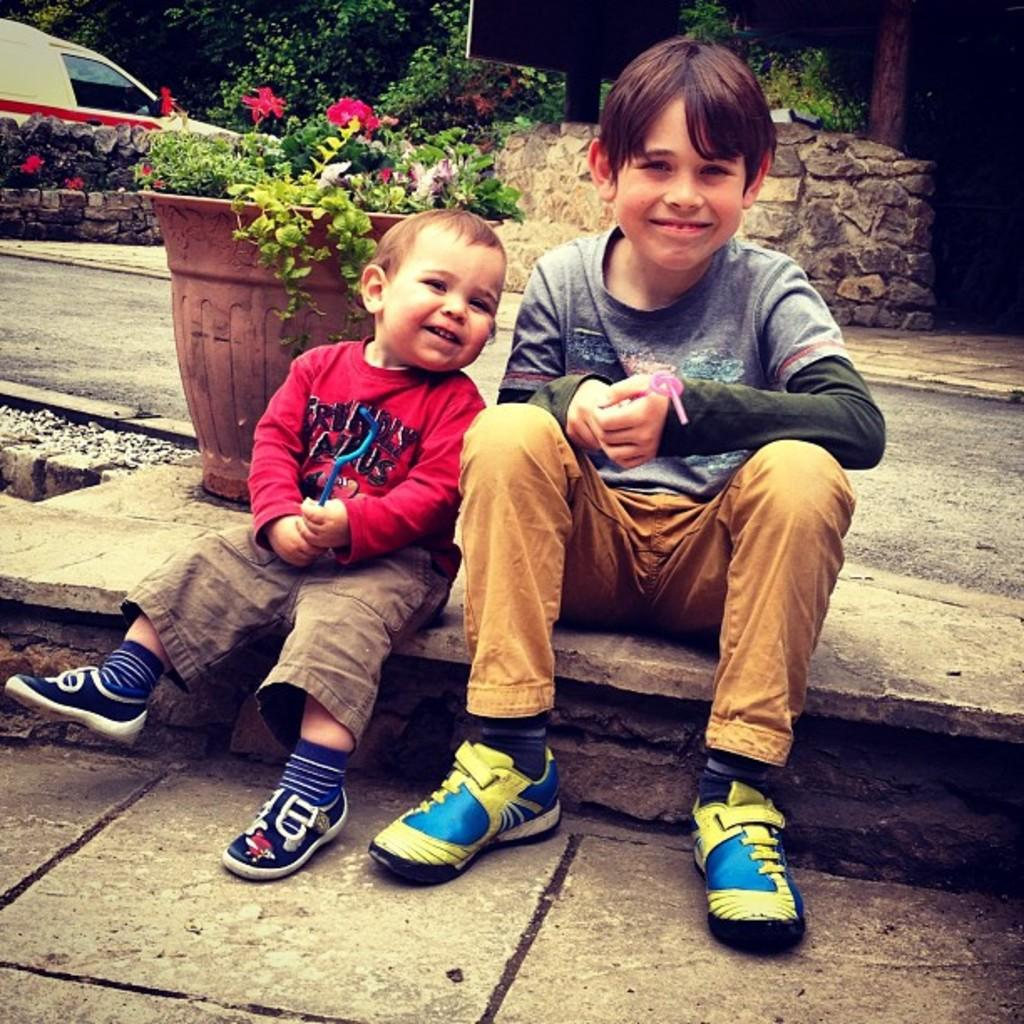How many kids are in the image? There are two kids in the image. What are the kids doing in the image? The kids are sitting and smiling. What can be seen in the background of the image? There is a vehicle, a flower pot, trees, and other objects in the background of the image. What type of brain can be seen in the image? There is no brain visible in the image. Are there any bears present in the image? There are no bears present in the image. 